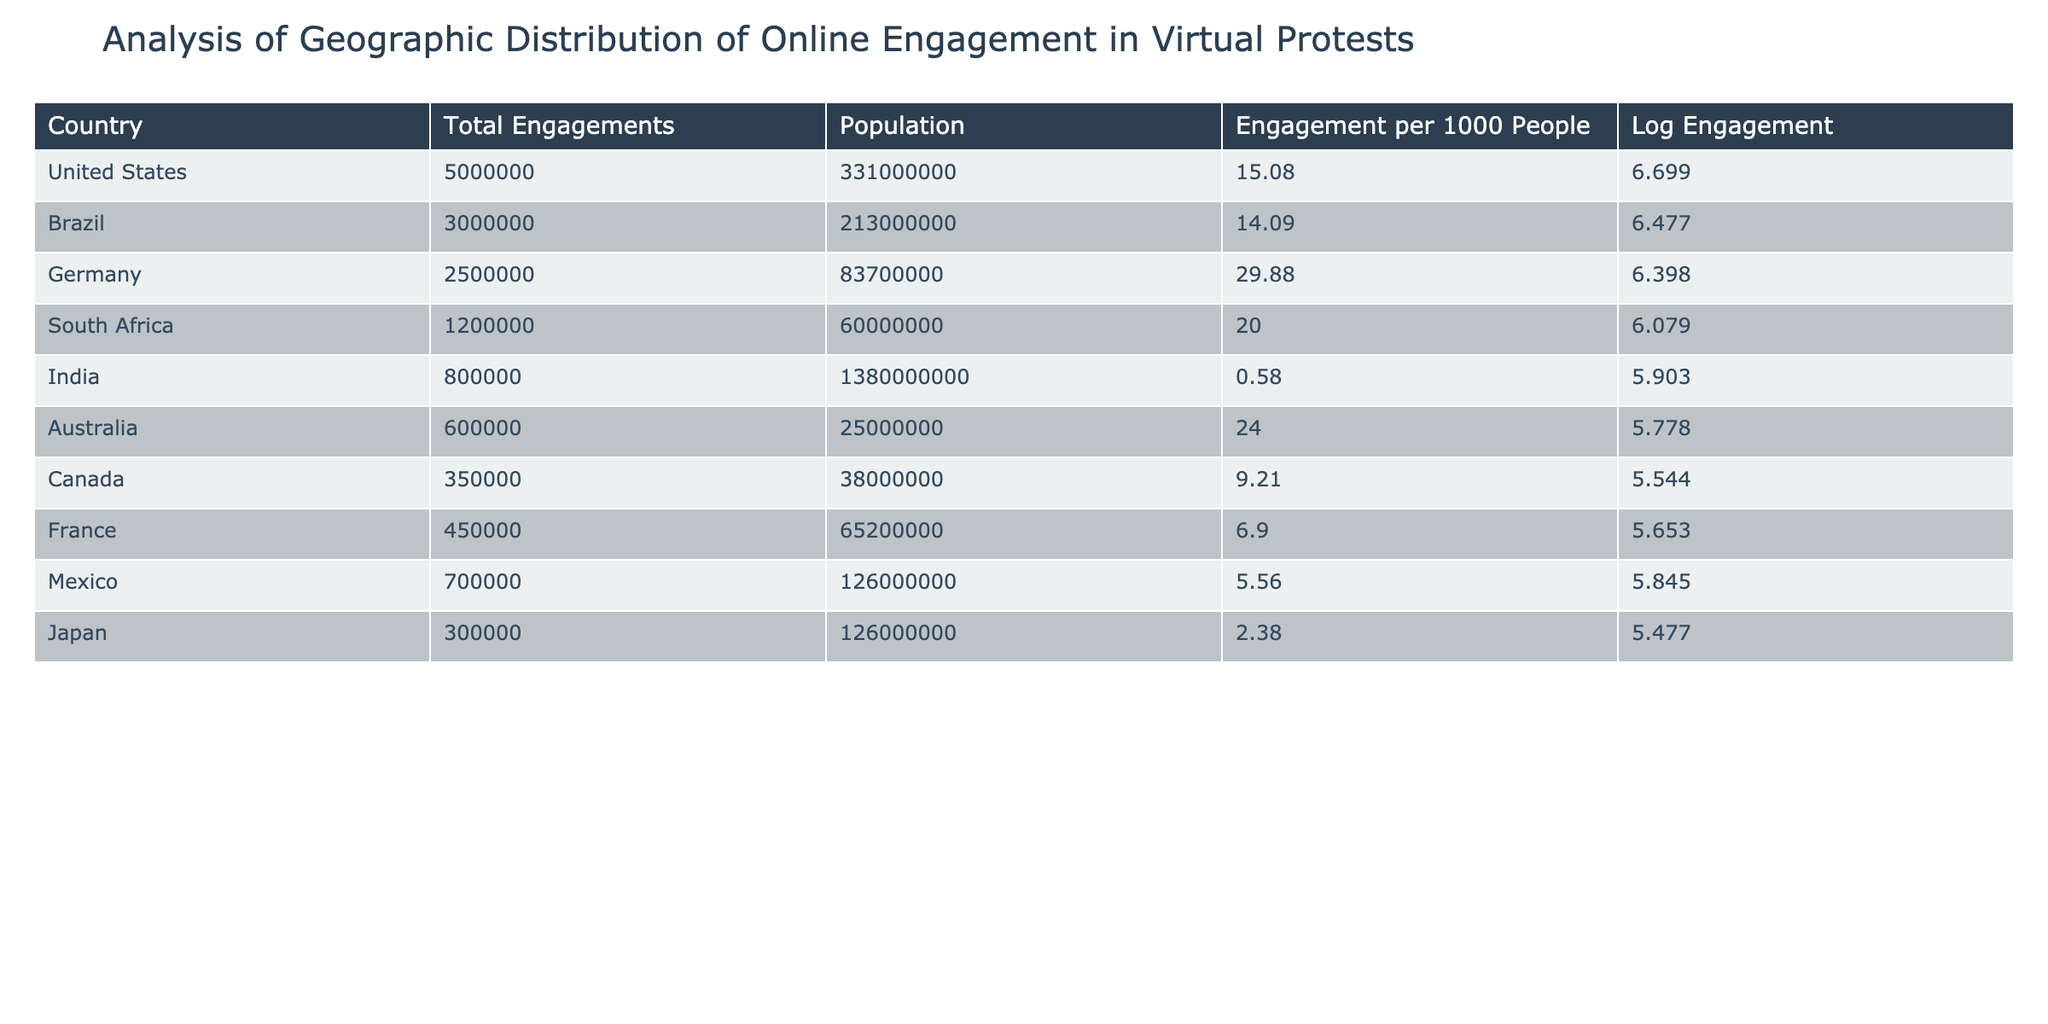What country has the highest total engagements in virtual protests? The table clearly shows the "Total Engagements" column. Looking down that column, the highest value is 5000000, which corresponds to the United States.
Answer: United States What is the engagement per 1000 people for Germany? In the "Engagement per 1000 People" column, Germany is listed with a value of 29.88.
Answer: 29.88 How many countries have an engagement per 1000 people greater than 20? We can filter the "Engagement per 1000 People" column for values greater than 20. In the table, South Africa (20.00) and Germany (29.88) are above 20. Counting these gives us 2 countries.
Answer: 2 Which countries have total engagements less than 1 million? We inspect the "Total Engagements" column to find any values less than 1000000. Checking each entry reveals that only India, with a total engagement of 800000, fits this criterion.
Answer: India What is the average engagement per 1000 people for the countries listed in the table? To calculate the average, first sum the engagements per 1000 people: (15.08 + 14.09 + 29.88 + 20.00 + 0.58 + 24.00 + 9.21 + 6.90 + 5.56 + 2.38) = 127.70. There are 10 countries, so the average is 127.70 / 10 = 12.77.
Answer: 12.77 Does Brazil have a higher engagement per 1000 people than Canada? Comparing the "Engagement per 1000 People" values, Brazil is listed with 14.09 and Canada with 9.21. Since 14.09 is greater than 9.21, Brazil does have a higher value.
Answer: Yes What is the difference in total engagements between South Africa and India? The "Total Engagements" for South Africa is 1200000 and for India, it is 800000. The difference is calculated as 1200000 - 800000 = 400000.
Answer: 400000 Which country has the lowest engagement in virtual protests based on the total engagements? In the "Total Engagements" column, after checking each value, India has the lowest at 800000.
Answer: India How many countries have a logarithmic engagement value greater than 6? Referring to the "Log Engagement" column, the countries with values above 6 are the United States, Brazil, and Germany. Counting these, we see there are 3 countries.
Answer: 3 